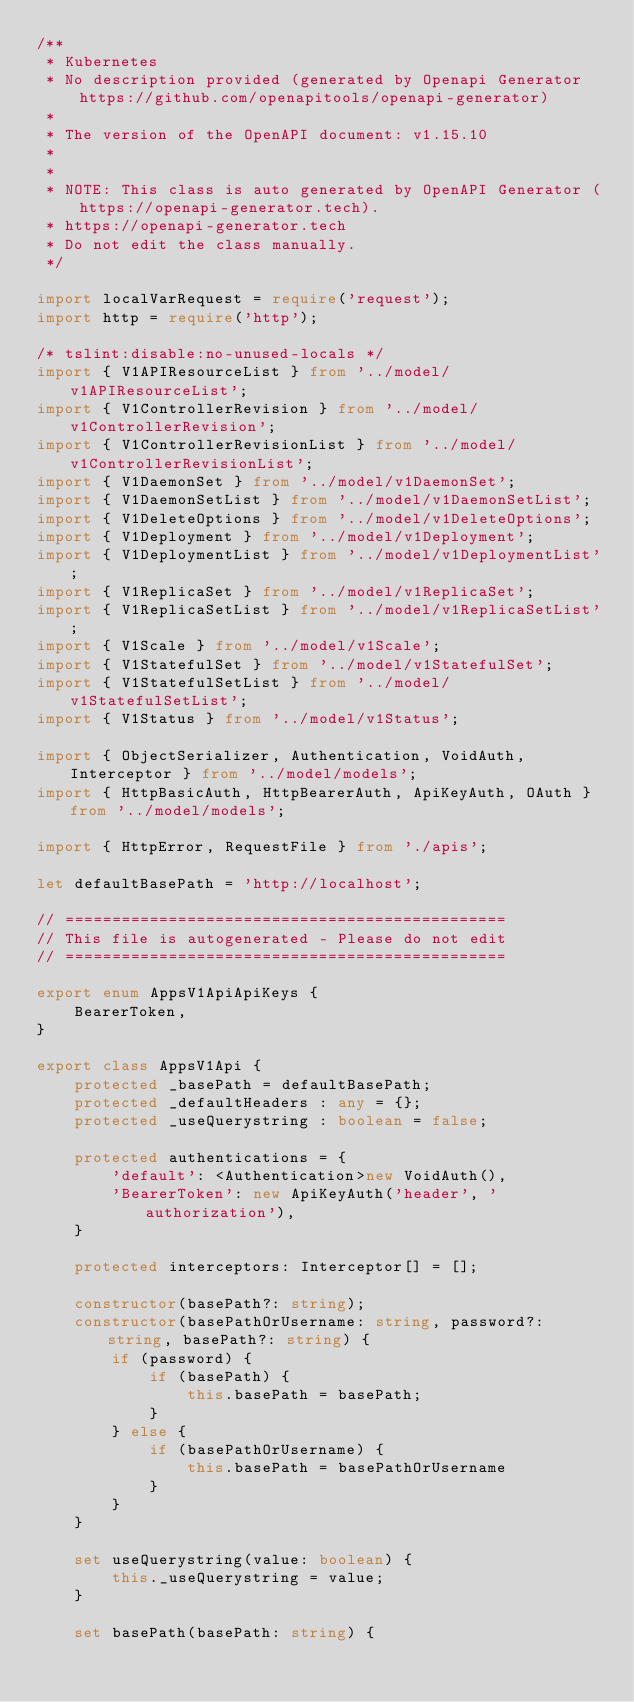Convert code to text. <code><loc_0><loc_0><loc_500><loc_500><_TypeScript_>/**
 * Kubernetes
 * No description provided (generated by Openapi Generator https://github.com/openapitools/openapi-generator)
 *
 * The version of the OpenAPI document: v1.15.10
 * 
 *
 * NOTE: This class is auto generated by OpenAPI Generator (https://openapi-generator.tech).
 * https://openapi-generator.tech
 * Do not edit the class manually.
 */

import localVarRequest = require('request');
import http = require('http');

/* tslint:disable:no-unused-locals */
import { V1APIResourceList } from '../model/v1APIResourceList';
import { V1ControllerRevision } from '../model/v1ControllerRevision';
import { V1ControllerRevisionList } from '../model/v1ControllerRevisionList';
import { V1DaemonSet } from '../model/v1DaemonSet';
import { V1DaemonSetList } from '../model/v1DaemonSetList';
import { V1DeleteOptions } from '../model/v1DeleteOptions';
import { V1Deployment } from '../model/v1Deployment';
import { V1DeploymentList } from '../model/v1DeploymentList';
import { V1ReplicaSet } from '../model/v1ReplicaSet';
import { V1ReplicaSetList } from '../model/v1ReplicaSetList';
import { V1Scale } from '../model/v1Scale';
import { V1StatefulSet } from '../model/v1StatefulSet';
import { V1StatefulSetList } from '../model/v1StatefulSetList';
import { V1Status } from '../model/v1Status';

import { ObjectSerializer, Authentication, VoidAuth, Interceptor } from '../model/models';
import { HttpBasicAuth, HttpBearerAuth, ApiKeyAuth, OAuth } from '../model/models';

import { HttpError, RequestFile } from './apis';

let defaultBasePath = 'http://localhost';

// ===============================================
// This file is autogenerated - Please do not edit
// ===============================================

export enum AppsV1ApiApiKeys {
    BearerToken,
}

export class AppsV1Api {
    protected _basePath = defaultBasePath;
    protected _defaultHeaders : any = {};
    protected _useQuerystring : boolean = false;

    protected authentications = {
        'default': <Authentication>new VoidAuth(),
        'BearerToken': new ApiKeyAuth('header', 'authorization'),
    }

    protected interceptors: Interceptor[] = [];

    constructor(basePath?: string);
    constructor(basePathOrUsername: string, password?: string, basePath?: string) {
        if (password) {
            if (basePath) {
                this.basePath = basePath;
            }
        } else {
            if (basePathOrUsername) {
                this.basePath = basePathOrUsername
            }
        }
    }

    set useQuerystring(value: boolean) {
        this._useQuerystring = value;
    }

    set basePath(basePath: string) {</code> 